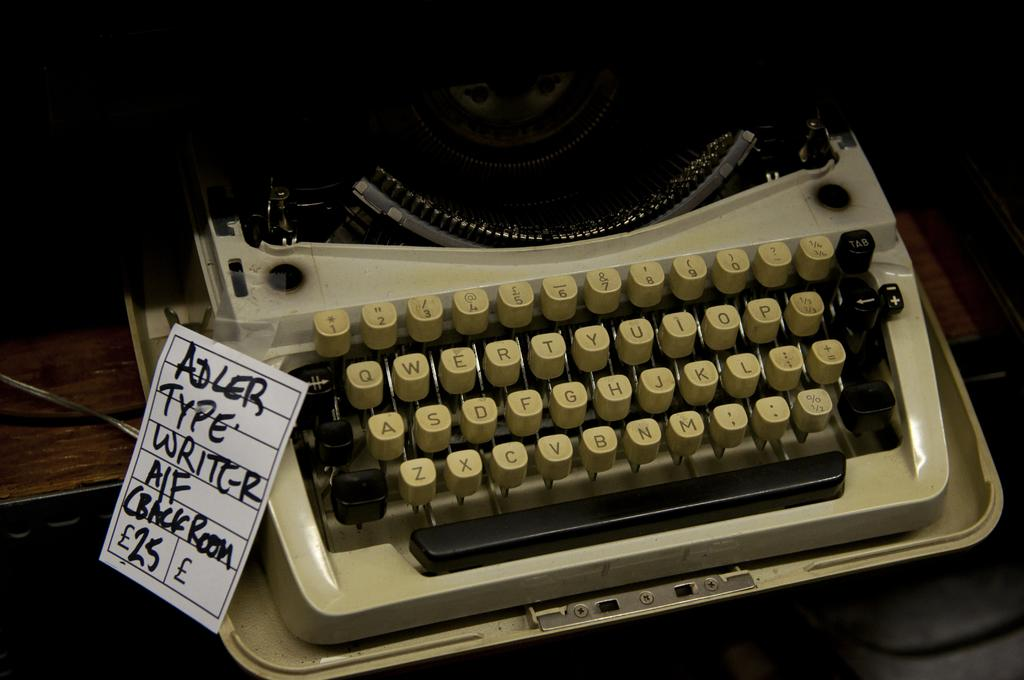What is the main object in the center of the image? There is a table in the center of the image. What is placed on the table? A typewriting machine, paper, and wire are present on the table. What might be used for writing or typing in the image? The typewriting machine on the table can be used for writing or typing. What is the lighting condition at the top of the image? The top part of the image is dark. What type of food is being prepared on the island in the image? There is no island or food preparation visible in the image; it features a table with a typewriting machine, paper, and wire. What type of tail can be seen on the animal in the image? There are no animals or tails present in the image. 